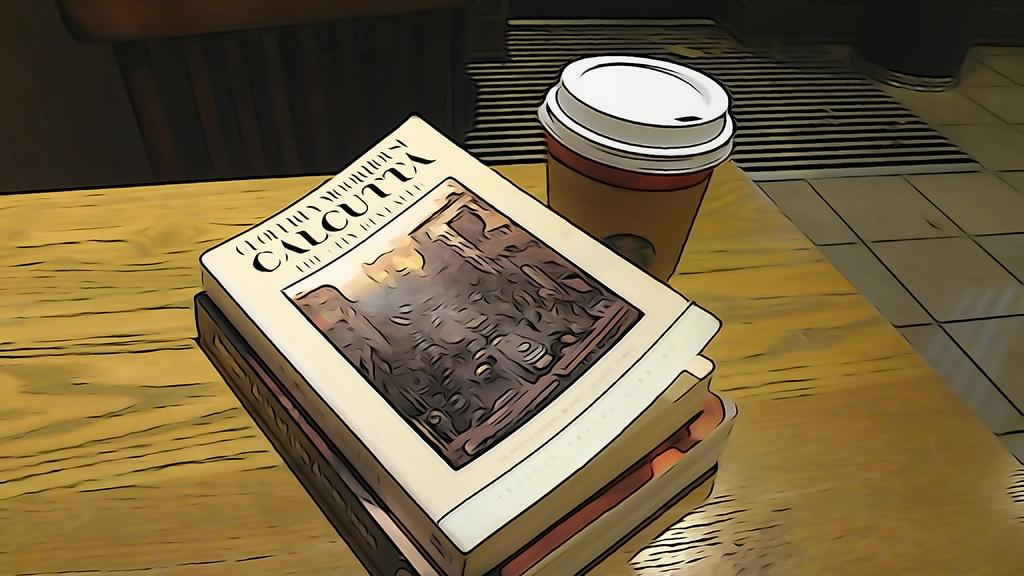<image>
Describe the image concisely. a book that says 'calcutta' on the top of it in black 